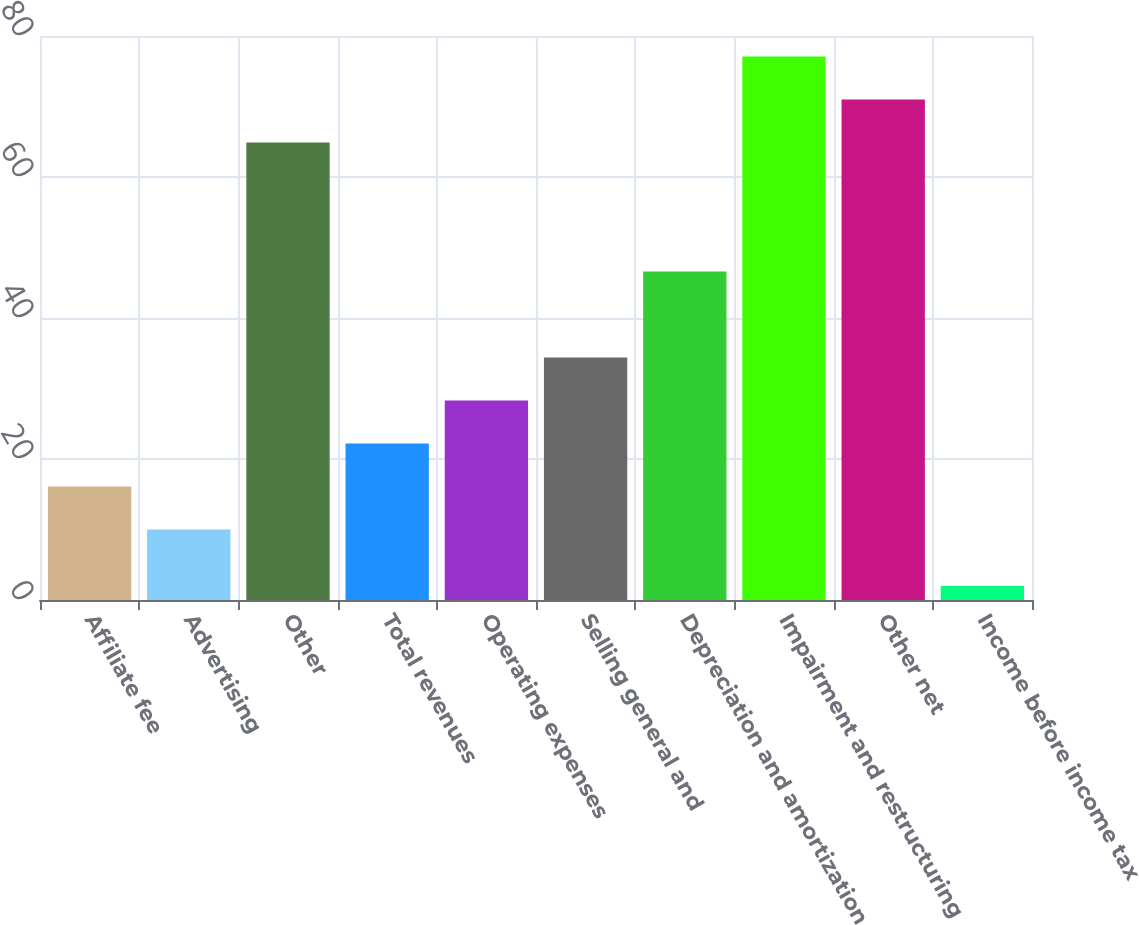Convert chart to OTSL. <chart><loc_0><loc_0><loc_500><loc_500><bar_chart><fcel>Affiliate fee<fcel>Advertising<fcel>Other<fcel>Total revenues<fcel>Operating expenses<fcel>Selling general and<fcel>Depreciation and amortization<fcel>Impairment and restructuring<fcel>Other net<fcel>Income before income tax<nl><fcel>16.1<fcel>10<fcel>64.9<fcel>22.2<fcel>28.3<fcel>34.4<fcel>46.6<fcel>77.1<fcel>71<fcel>2<nl></chart> 